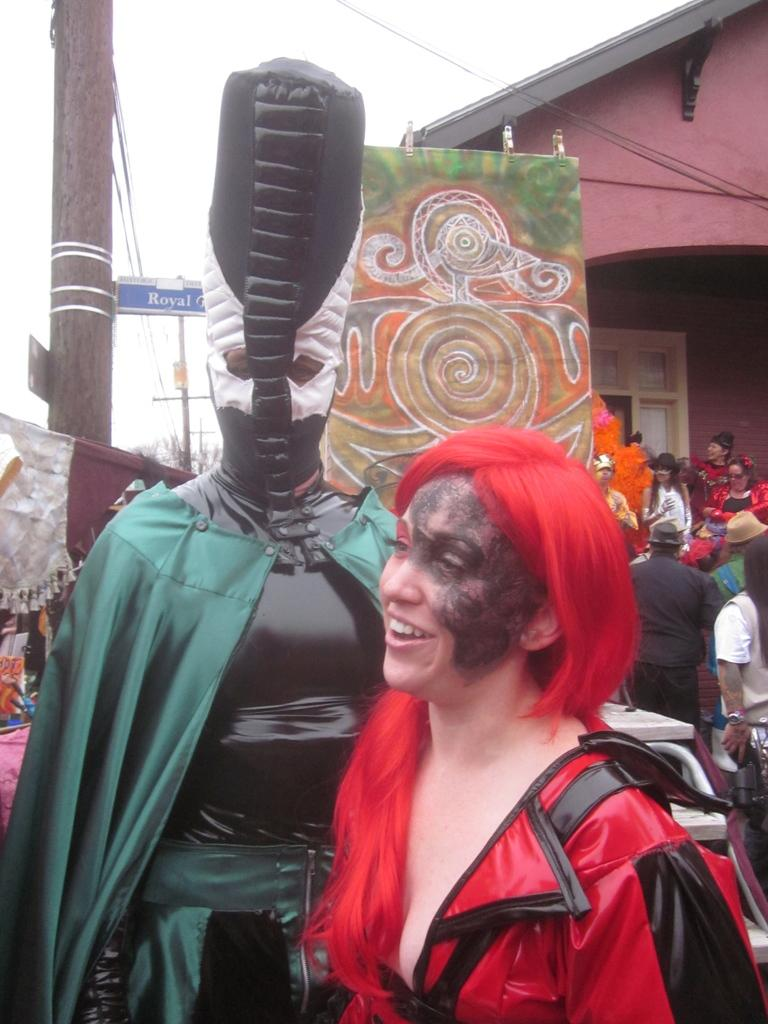How many people are in the image? There are two persons in the image. What are the two persons wearing? The two persons are wearing different costumes. What can be seen in the background of the image? There is a house in the background of the image. Are there any other people with costumes in the image? Yes, there are people with costumes in front of the house. What type of pest can be seen crawling on the costumes of the persons in the image? There are no pests visible in the image; the persons are wearing costumes. What is the title of the image? The provided facts do not include a title for the image. 